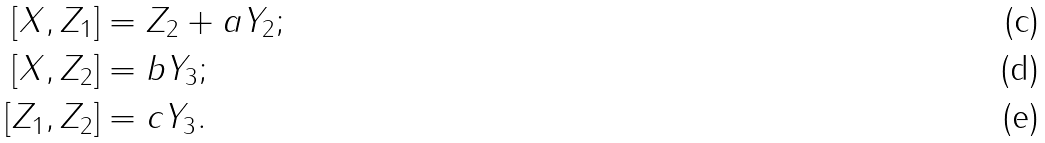Convert formula to latex. <formula><loc_0><loc_0><loc_500><loc_500>[ X , Z _ { 1 } ] & = Z _ { 2 } + a Y _ { 2 } ; \\ [ X , Z _ { 2 } ] & = b Y _ { 3 } ; \\ [ Z _ { 1 } , Z _ { 2 } ] & = c Y _ { 3 } .</formula> 